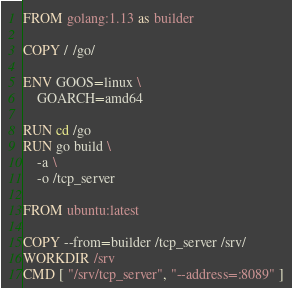<code> <loc_0><loc_0><loc_500><loc_500><_Dockerfile_>FROM golang:1.13 as builder

COPY / /go/

ENV GOOS=linux \
    GOARCH=amd64

RUN cd /go
RUN go build \
    -a \
    -o /tcp_server

FROM ubuntu:latest

COPY --from=builder /tcp_server /srv/
WORKDIR /srv
CMD [ "/srv/tcp_server", "--address=:8089" ]</code> 